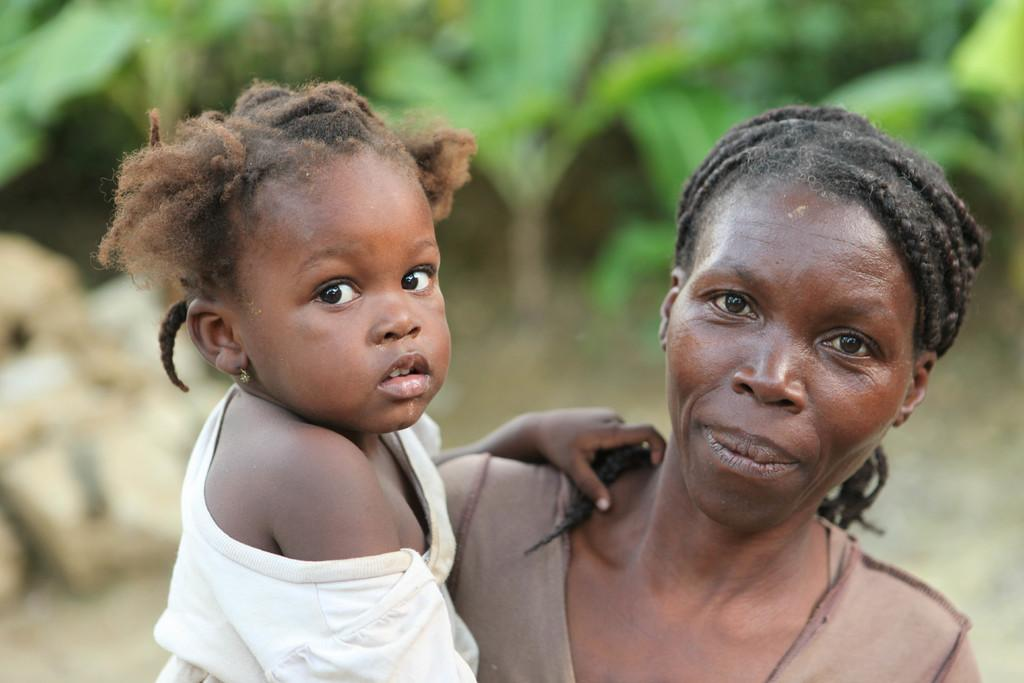Who is present in the image? There is a woman and a kid in the image. Where are the woman and the kid located in the image? The woman and the kid are in the front of the image. What can be seen in the background of the image? There are plants in the background of the image. How would you describe the background in the image? The background appears blurry. What type of record is the woman holding in the image? There is no record present in the image. Can you hear the father laughing in the image? There is no audio or indication of a father in the image, so it is not possible to hear any laughter. 